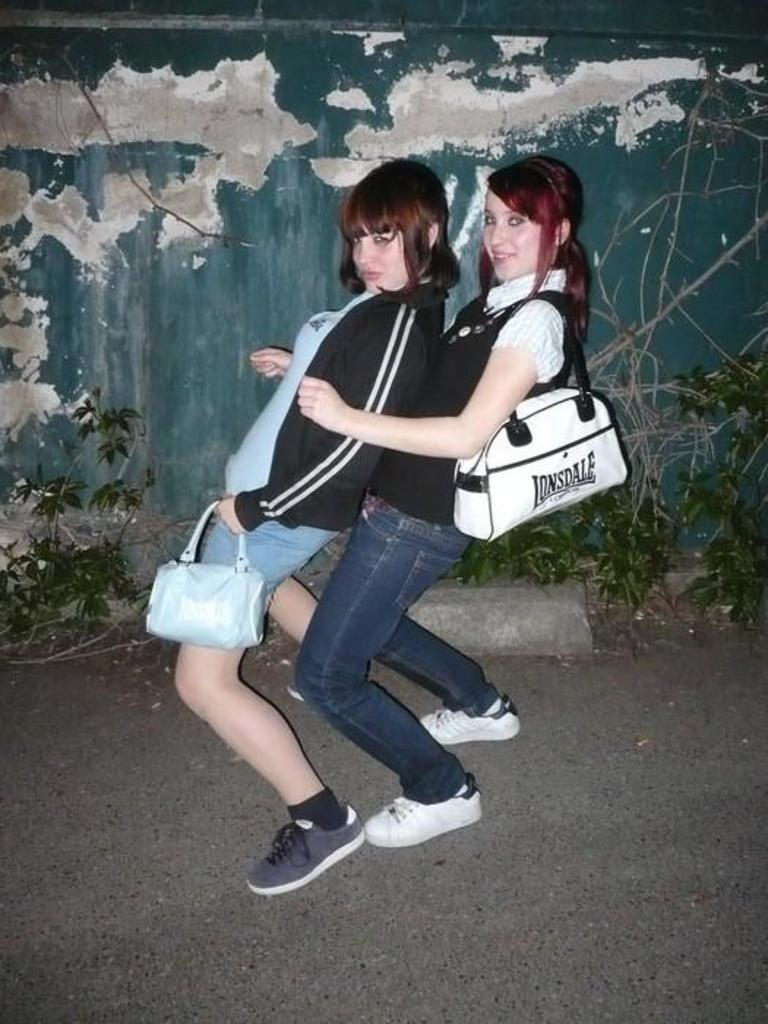How many people are present in the image? There are two people in the image. What are the people wearing on their feet? The people are wearing shoes. What are the people holding in their hands? The people are holding bags. What can be seen in the background of the image? There are plants and a wall in the background of the image. What type of jam is being spread on the earth in the image? There is no jam or spreading activity present in the image. 